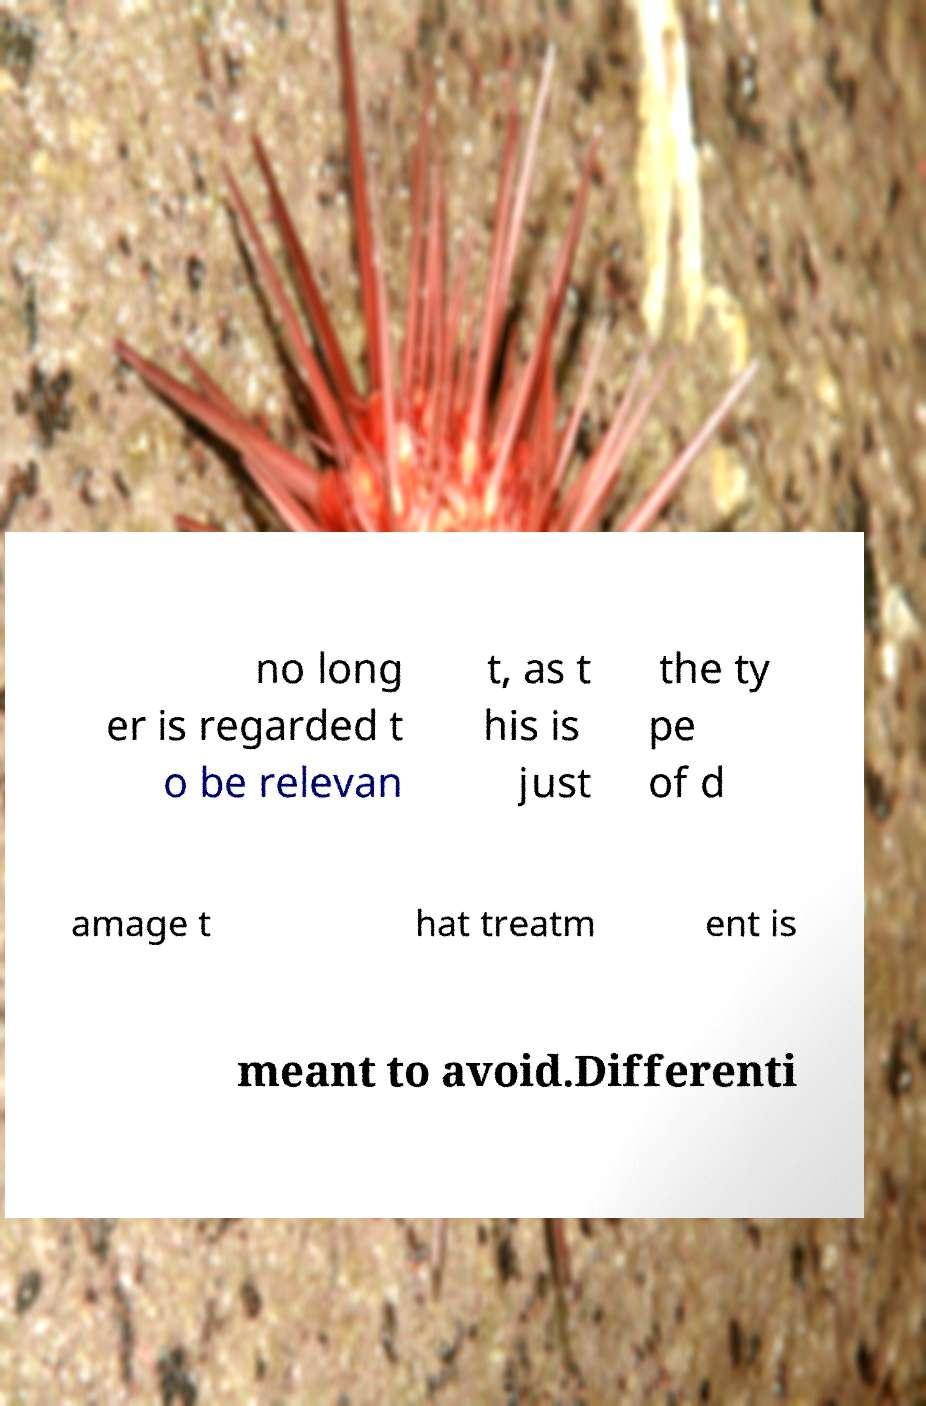Could you extract and type out the text from this image? no long er is regarded t o be relevan t, as t his is just the ty pe of d amage t hat treatm ent is meant to avoid.Differenti 